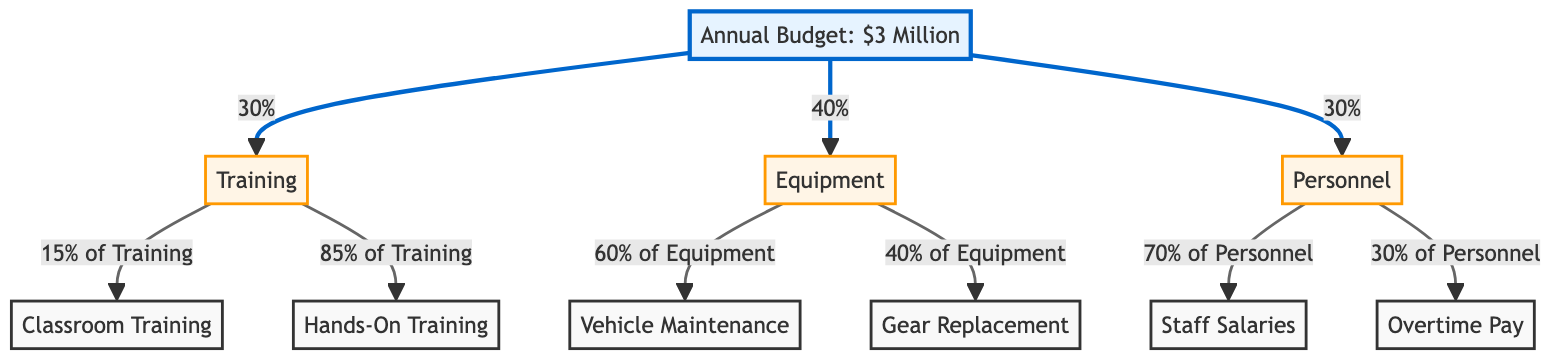What is the total annual budget allocated for the fire department? The annual budget is explicitly stated in the diagram as 3 million dollars.
Answer: 3 Million What percentage of the budget is allocated to Equipment? The diagram indicates that 40% of the annual budget is designated for Equipment.
Answer: 40% How much of the Training budget is allocated to Hands-On Training? According to the diagram, 85% of the Training budget goes to Hands-On Training.
Answer: 85% What is the main category that receives the least budget allocation? The categories are Training, Equipment, and Personnel, with Training and Personnel each receiving 30%, while Equipment gets 40%, making Training and Personnel the least allocated.
Answer: Training and Personnel What proportion of Equipment funds is used for Vehicle Maintenance? The diagram shows that 60% of the Equipment budget is allocated specifically for Vehicle Maintenance.
Answer: 60% If the Personnel budget is $900,000, how much is allocated for Staff Salaries? Since Personnel comprises 30% of the total budget ($3 million), it amounts to $900,000. Of this, 70% is allocated for Staff Salaries, which equals $630,000.
Answer: $630,000 How many subcategories are there under Training? The diagram shows two subcategories under Training: Classroom Training and Hands-On Training, making it a total of 2 subcategories.
Answer: 2 What is the ratio of budget allocation between Classroom Training and Hands-On Training? The allocation is 15% for Classroom Training and 85% for Hands-On Training, thus the ratio is 15:85 or simplified 3:17.
Answer: 3:17 Which category receives the highest allocation for Overtime Pay? The diagram shows that Overtime Pay falls under the Personnel category, which is the only category that allocates funding for Overtime Pay.
Answer: Personnel 